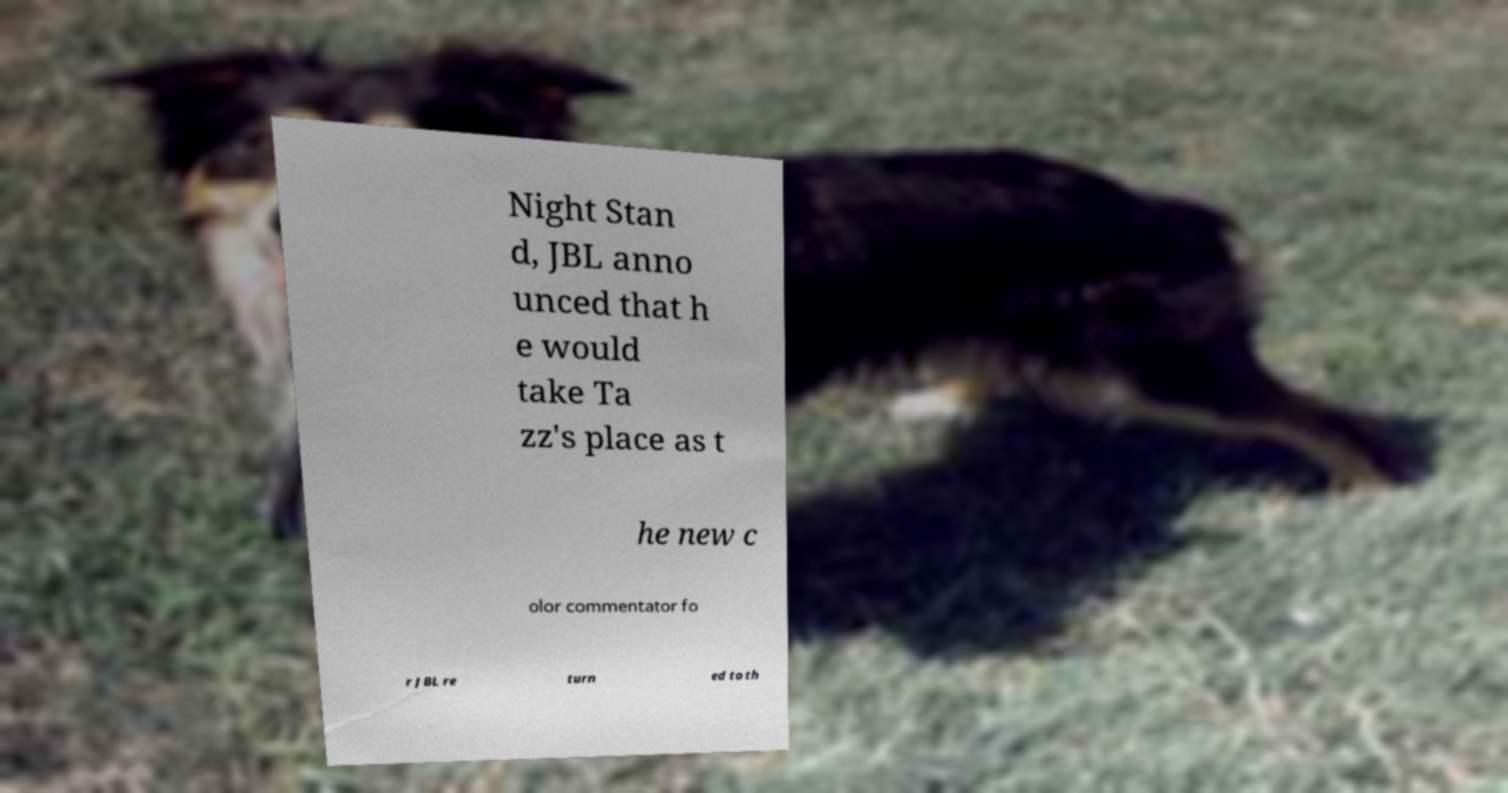There's text embedded in this image that I need extracted. Can you transcribe it verbatim? Night Stan d, JBL anno unced that h e would take Ta zz's place as t he new c olor commentator fo r JBL re turn ed to th 